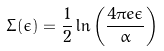<formula> <loc_0><loc_0><loc_500><loc_500>\Sigma ( \epsilon ) = \frac { 1 } { 2 } \ln \left ( \frac { 4 \pi e \epsilon } { \alpha } \right )</formula> 